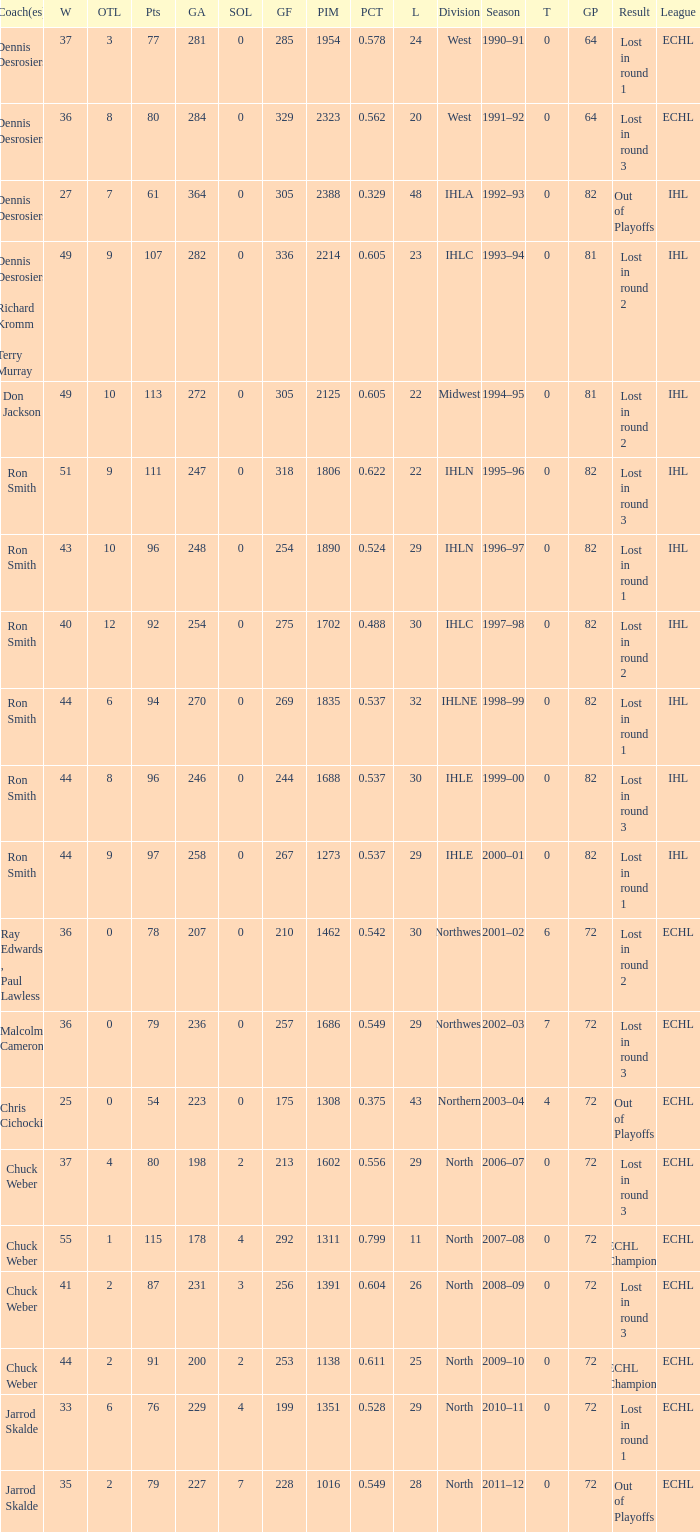What was the maximum OTL if L is 28? 2.0. 